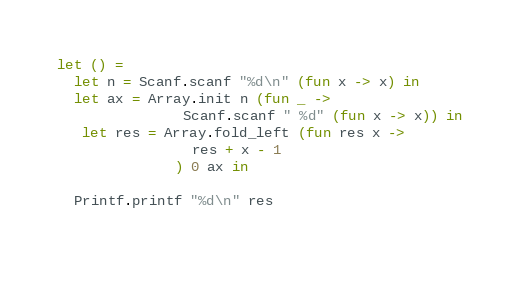<code> <loc_0><loc_0><loc_500><loc_500><_OCaml_>let () =
  let n = Scanf.scanf "%d\n" (fun x -> x) in
  let ax = Array.init n (fun _ ->
               Scanf.scanf " %d" (fun x -> x)) in
   let res = Array.fold_left (fun res x ->
                res + x - 1
              ) 0 ax in
  
  Printf.printf "%d\n" res
  </code> 